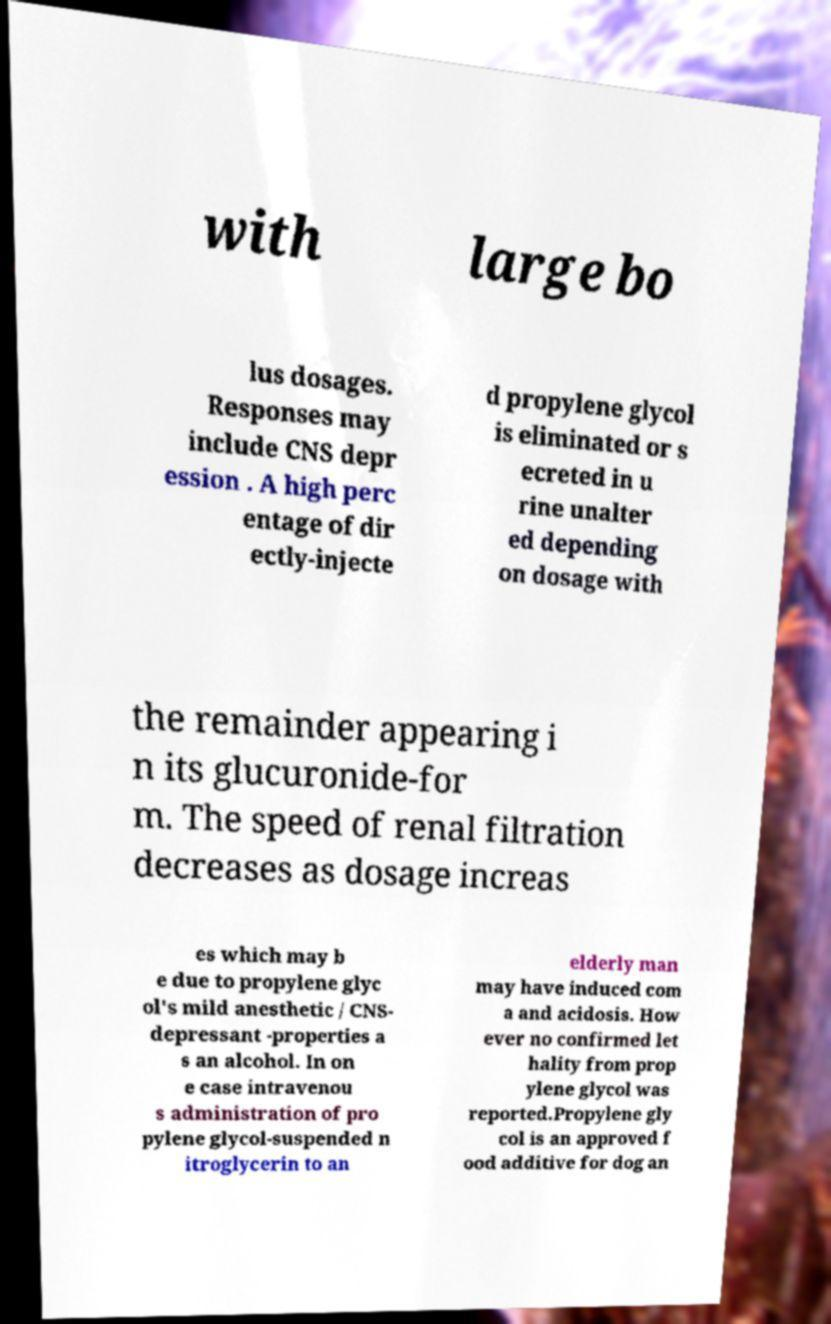There's text embedded in this image that I need extracted. Can you transcribe it verbatim? with large bo lus dosages. Responses may include CNS depr ession . A high perc entage of dir ectly-injecte d propylene glycol is eliminated or s ecreted in u rine unalter ed depending on dosage with the remainder appearing i n its glucuronide-for m. The speed of renal filtration decreases as dosage increas es which may b e due to propylene glyc ol's mild anesthetic / CNS- depressant -properties a s an alcohol. In on e case intravenou s administration of pro pylene glycol-suspended n itroglycerin to an elderly man may have induced com a and acidosis. How ever no confirmed let hality from prop ylene glycol was reported.Propylene gly col is an approved f ood additive for dog an 